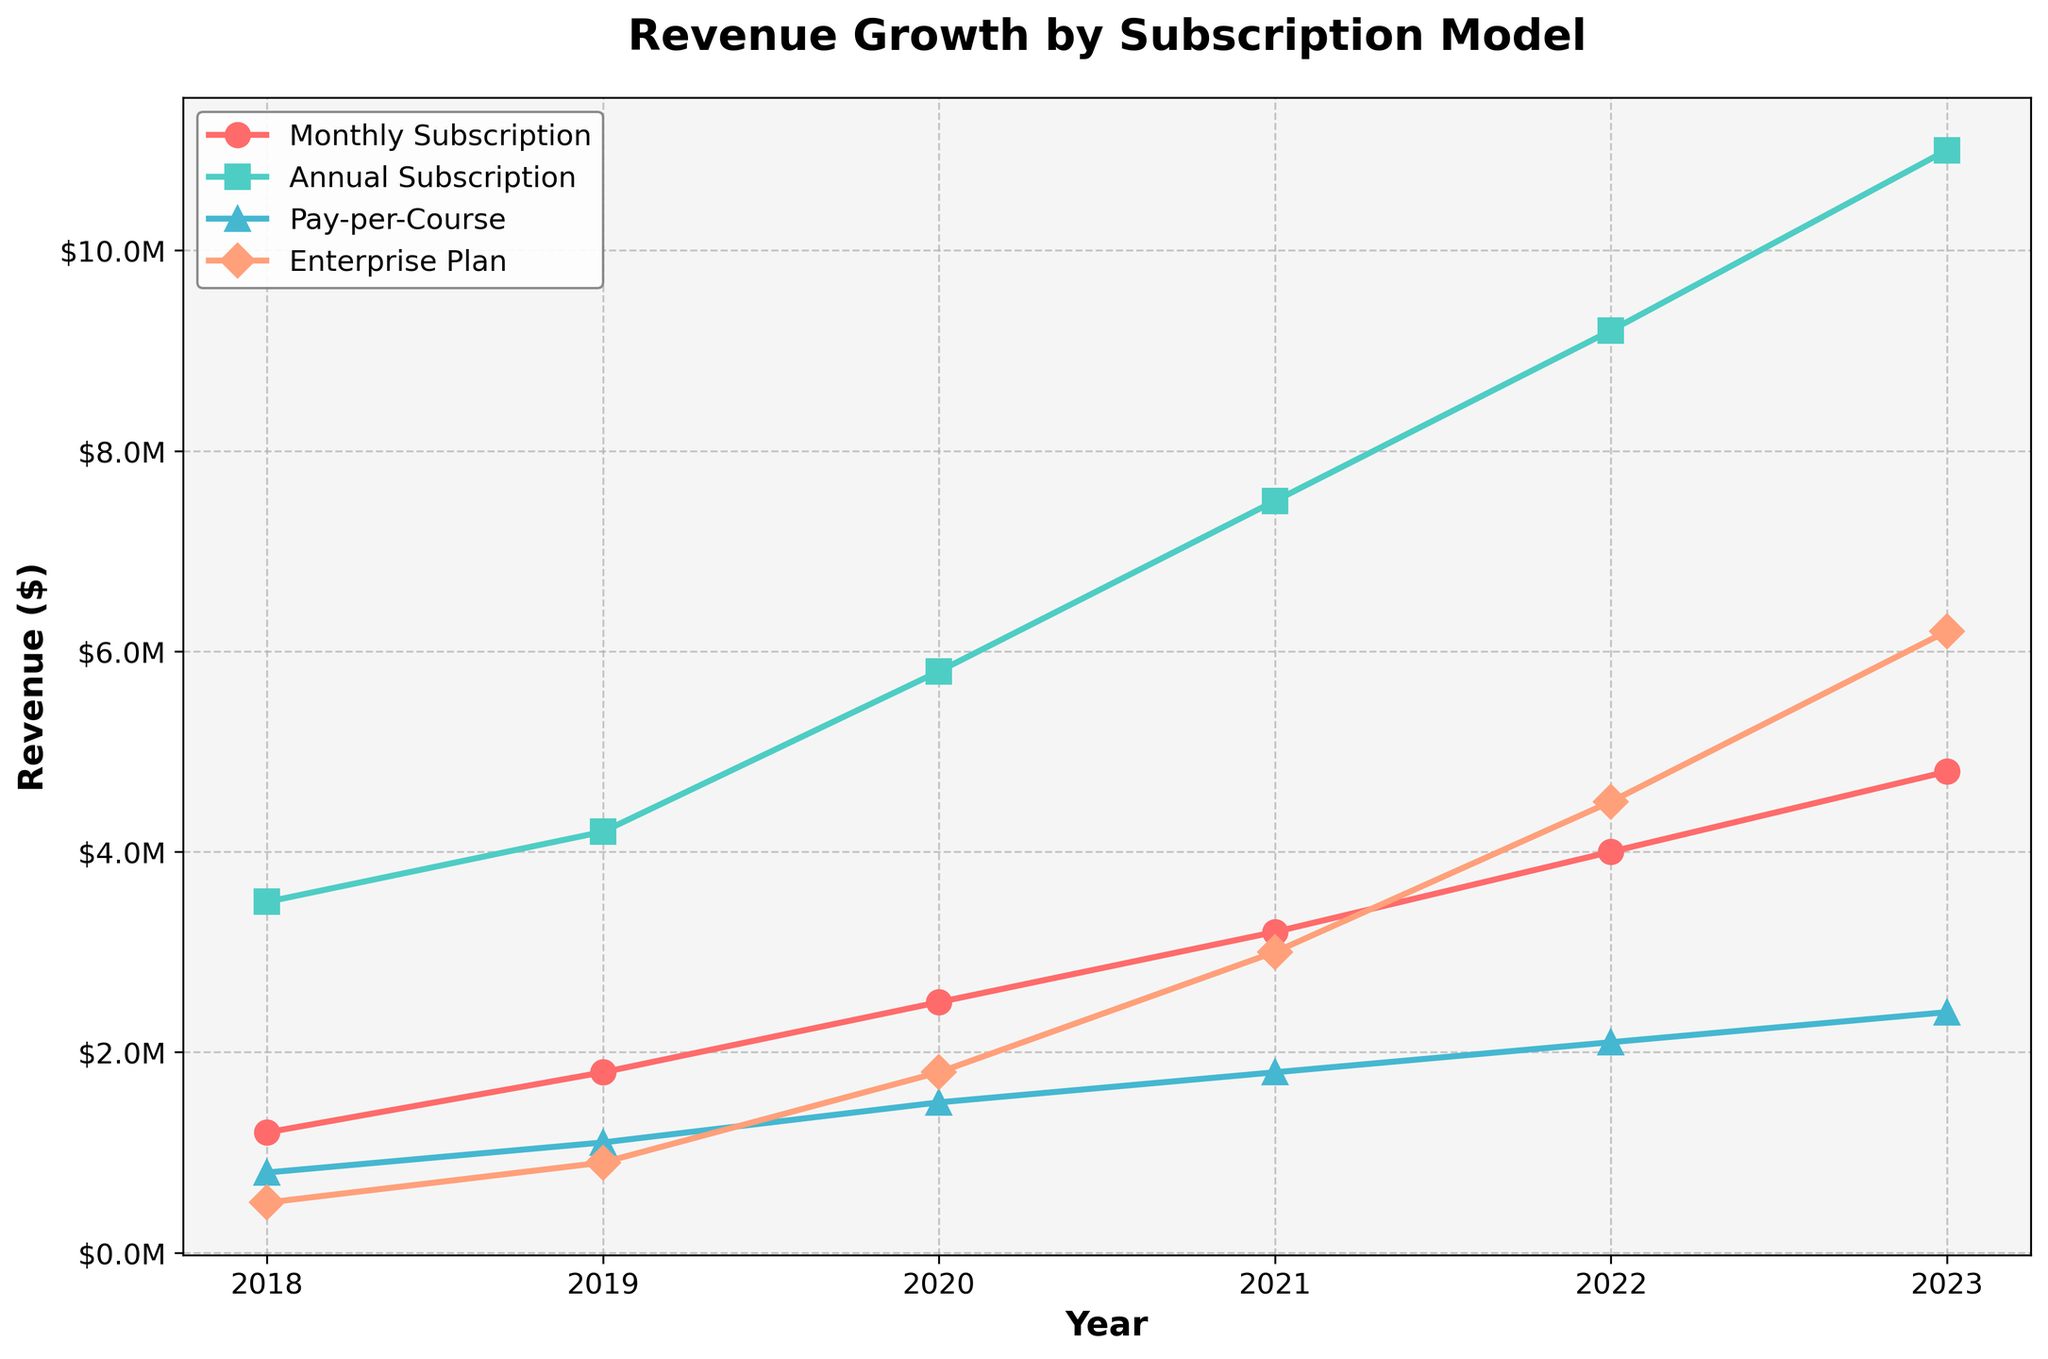What is the overall trend in revenue for the Monthly Subscription from 2018 to 2023? The Monthly Subscription revenue shows a consistent upward trend. From 2018's $1.2M, it grows steadily each year, reaching $4.8M by 2023.
Answer: Consistent increase Which subscription model had the highest revenue in 2023? By comparing the revenue values in 2023, the Annual Subscription has the highest revenue at $11M, surpassing other models.
Answer: Annual Subscription How does the revenue growth of the Enterprise Plan between 2018 and 2023 compare to the Pay-per-Course model in the same period? In 2018, the Enterprise Plan started at $0.5M and grew to $6.2M in 2023. Comparatively, Pay-per-Course started at $0.8M and increased to $2.4M. The Enterprise Plan grew by $5.7M, while Pay-per-Course grew by $1.6M.
Answer: Enterprise Plan grew more In which year did the Annual Subscription model first surpass $7M? Observing the trend in the Annual Subscription data, it first surpassed $7M in 2021 with revenue of $7.5M.
Answer: 2021 Which model had the least revenue growth from 2018 to 2023? The Pay-per-Course model shows the least growth, starting at $0.8M in 2018 and reaching $2.4M in 2023, a growth of $1.6M.
Answer: Pay-per-Course Between which consecutive years did the Monthly Subscription model experience the highest absolute revenue increase? Calculating the differences: 2018-2019 ($0.6M), 2019-2020 ($0.7M), 2020-2021 ($0.7M), 2021-2022 ($0.8M), 2022-2023 ($0.8M). The highest increase was between 2021-2022 and 2022-2023 at $0.8M each.
Answer: 2021-2022 and 2022-2023 What is the total revenue for all models combined in 2020? Summing up all the 2020 revenue values: Monthly Subscription ($2.5M) + Annual Subscription ($5.8M) + Pay-per-Course ($1.5M) + Enterprise Plan ($1.8M) = $11.6M.
Answer: $11.6M How does the 2022 revenue from the Enterprise Plan compare to the 2019 revenue from the Annual Subscription? In 2022, the Enterprise Plan is $4.5M. In 2019, the Annual Subscription is $4.2M. Therefore, the Enterprise Plan's revenue in 2022 is higher by $0.3M.
Answer: Enterprise Plan higher by $0.3M What color is used to represent the Annual Subscription model? The Annual Subscription model is represented by the line colored green.
Answer: Green 